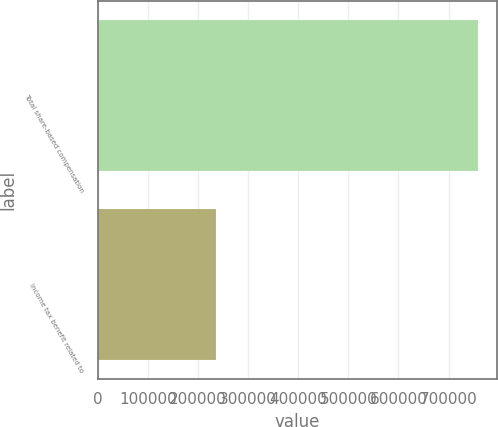<chart> <loc_0><loc_0><loc_500><loc_500><bar_chart><fcel>Total share-based compensation<fcel>Income tax benefit related to<nl><fcel>758176<fcel>236423<nl></chart> 